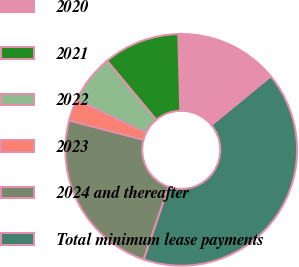Convert chart. <chart><loc_0><loc_0><loc_500><loc_500><pie_chart><fcel>2020<fcel>2021<fcel>2022<fcel>2023<fcel>2024 and thereafter<fcel>Total minimum lease payments<nl><fcel>14.47%<fcel>10.66%<fcel>6.84%<fcel>3.03%<fcel>23.83%<fcel>41.18%<nl></chart> 